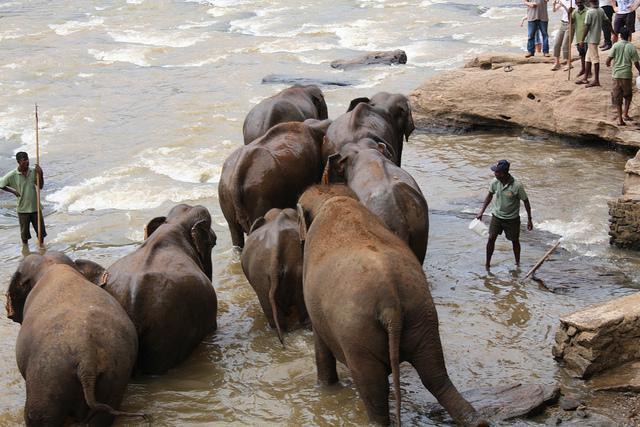Why is the person on the right of the elephants holding a bucket?
Indicate the correct choice and explain in the format: 'Answer: answer
Rationale: rationale.'
Options: Catch spit, throw mud, help wash, catch poop. Answer: help wash.
Rationale: Two men are standing around elephants in water. buckets can be used to scoop water. 